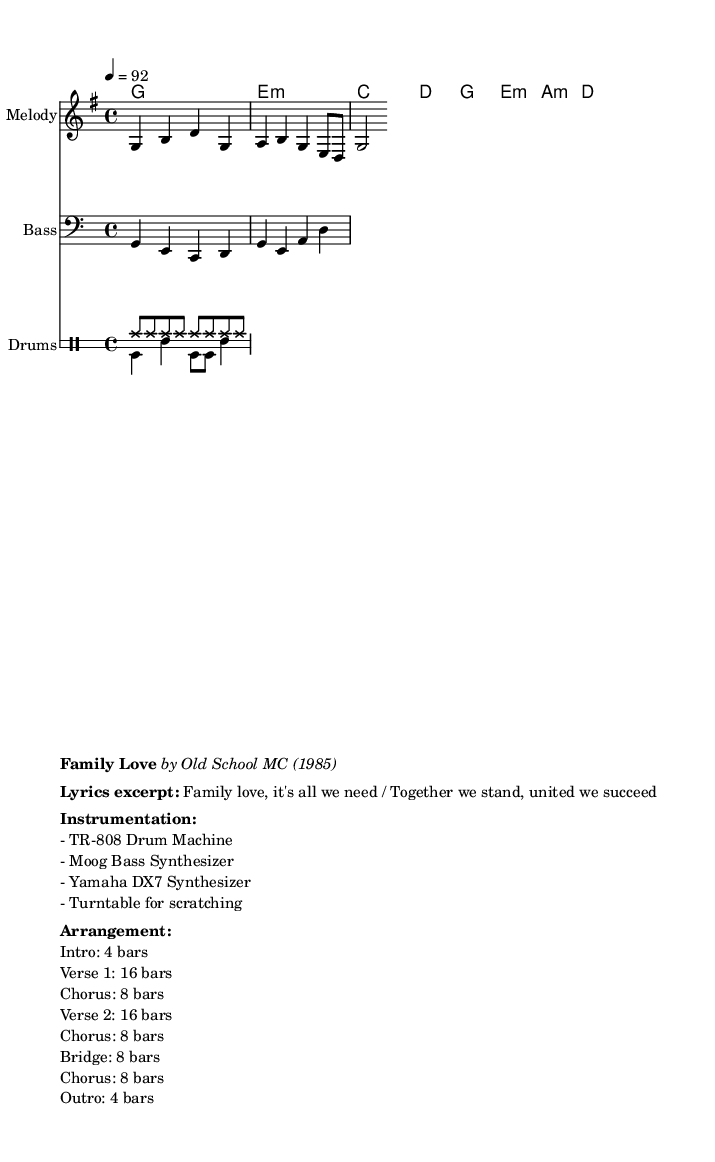What is the key signature of this music? The key signature is G major, which has one sharp (F#). This can be identified by looking at the key signature at the beginning of the music.
Answer: G major What is the time signature of this composition? The time signature is 4/4. This is indicated at the beginning of the sheet music, showing that there are four beats in each measure and the quarter note gets one beat.
Answer: 4/4 What is the tempo marking for the piece? The tempo is set at 92 beats per minute, indicated at the top of the sheet music. The marking tells us how fast to perform the music.
Answer: 92 How many bars are in the intro section? The intro section consists of 4 bars, as stated in the arrangement section of the sheet music. Therefore, you look at the arrangement to find the length of the intro.
Answer: 4 bars What is the instrument primarily featured in the melody? The instrument featured in the melody is the "Melody" staff, which suggests a lead instrument or voice is playing the melody. This can be inferred from the naming of the staff.
Answer: Melody What type of drum machine is used in this piece? The drum machine used is a TR-808, which is noted clearly in the instrumentation section of the sheet music. This specific machine is iconic in hip hop music, particularly in the 1980s.
Answer: TR-808 What do the lyrics in the excerpt emphasize? The lyrics emphasize family unity and success, as indicated by the lines "Family love, it's all we need / Together we stand, united we succeed." This reflects a positive, family-oriented message central to the song.
Answer: Family unity 